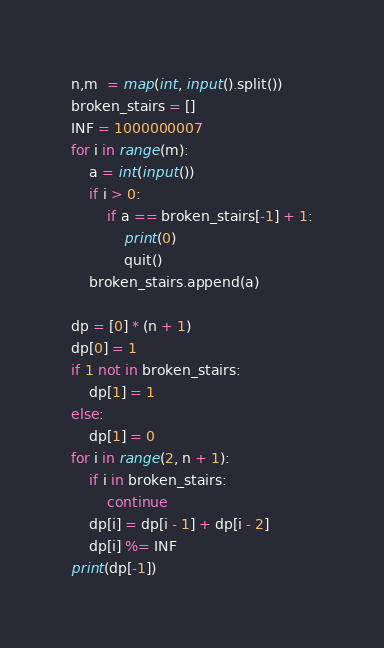Convert code to text. <code><loc_0><loc_0><loc_500><loc_500><_Python_>n,m  = map(int, input().split())
broken_stairs = []
INF = 1000000007
for i in range(m):
    a = int(input())
    if i > 0:
        if a == broken_stairs[-1] + 1:
            print(0)
            quit()
    broken_stairs.append(a)

dp = [0] * (n + 1)
dp[0] = 1
if 1 not in broken_stairs:
	dp[1] = 1
else:
	dp[1] = 0
for i in range(2, n + 1):
	if i in broken_stairs:
		continue
	dp[i] = dp[i - 1] + dp[i - 2]
	dp[i] %= INF
print(dp[-1])
</code> 